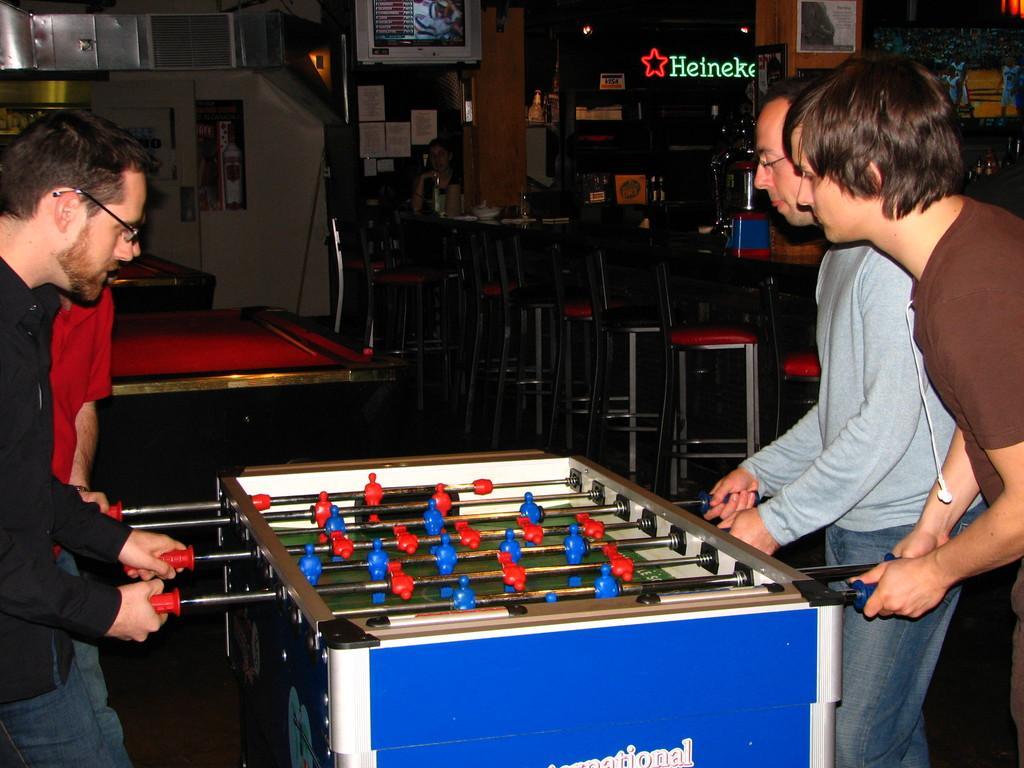Could you give a brief overview of what you see in this image? In this picture we can see some people are playing Foosball, behind we can see some chairs, tables are arranged. 